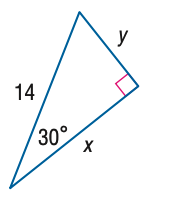Question: Find y.
Choices:
A. 7
B. 7 \sqrt { 2 }
C. 7 \sqrt { 3 }
D. 14
Answer with the letter. Answer: A 